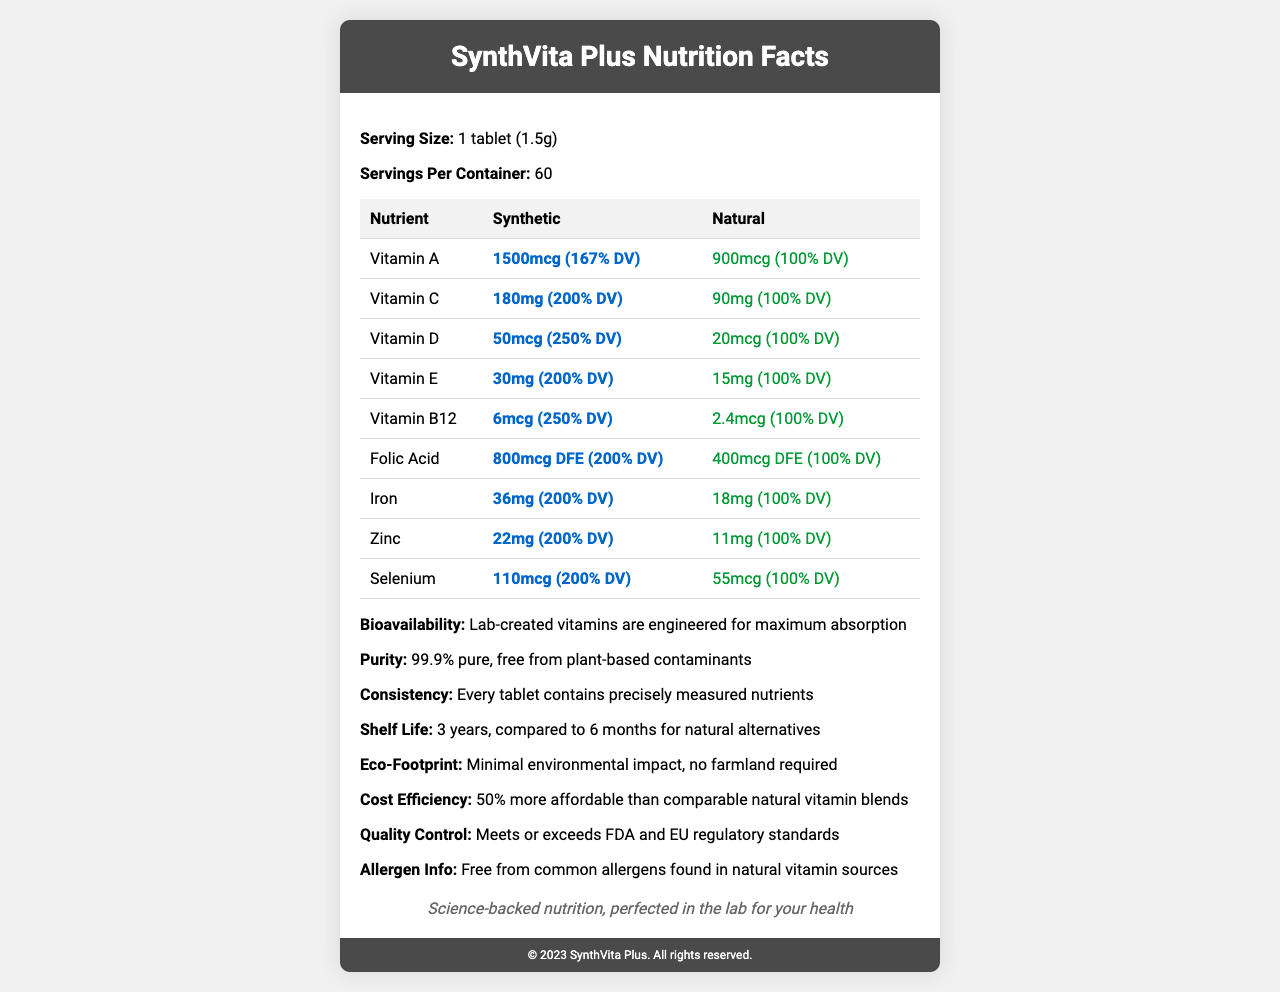what is the serving size of SynthVita Plus? The document clearly states that the serving size is 1 tablet (1.5g).
Answer: 1 tablet (1.5g) how many servings per container are there? According to the document, there are 60 servings per container.
Answer: 60 what is the shelf life of SynthVita Plus? The shelf life of SynthVita Plus is listed as 3 years in the document.
Answer: 3 years what percentage of Daily Value (% DV) does synthetic Vitamin C provide? The document shows that synthetic Vitamin C provides 200% of the Daily Value (% DV).
Answer: 200% DV what is the cost efficiency of SynthVita Plus compared to natural vitamin blends? The document states that SynthVita Plus is 50% more affordable than comparable natural vitamin blends.
Answer: 50% more affordable which vitamin has the highest % DV in its synthetic form? 
1. Vitamin A
2. Vitamin C
3. Vitamin D
4. Vitamin B12 Vitamin D in its synthetic form has the highest % DV of 250%.
Answer: 3. Vitamin D which of the following vitamins has the same % DV between synthetic and natural forms?
I. Vitamin B12
II. Vitamin E
III. Selenium The % DV for all listed vitamins (Vitamin B12, Vitamin E, Selenium) differs between synthetic and natural forms.
Answer: None of the above are synthetic vitamins more bioavailable than natural ones according to the document? The document includes a statement that lab-created vitamins are engineered for maximum absorption, implying higher bioavailability.
Answer: Yes does the document claim that SynthVita Plus meets FDA and EU regulatory standards? The document mentions that SynthVita Plus meets or exceeds FDA and EU regulatory standards.
Answer: Yes summarize the main idea of the document. The main idea revolves around promoting the advantages of SynthVita Plus, a synthetic vitamin product, by comparing it to natural alternatives across various metrics and emphasizing its engineered benefits.
Answer: The document is a nutrition facts label for SynthVita Plus, showcasing its superiority over natural vitamins. It highlights key metrics such as serving size, % Daily Value of vitamins, bioavailability, purity, consistency, shelf life, eco-footprint, cost efficiency, and allergens. It emphasizes the benefits of synthetic vitamins in terms of nutrient content, purity, and regulatory compliance. what agricultural practices are used to produce SynthVita Plus? The document does not provide any information about agricultural practices for producing SynthVita Plus.
Answer: Cannot be determined 